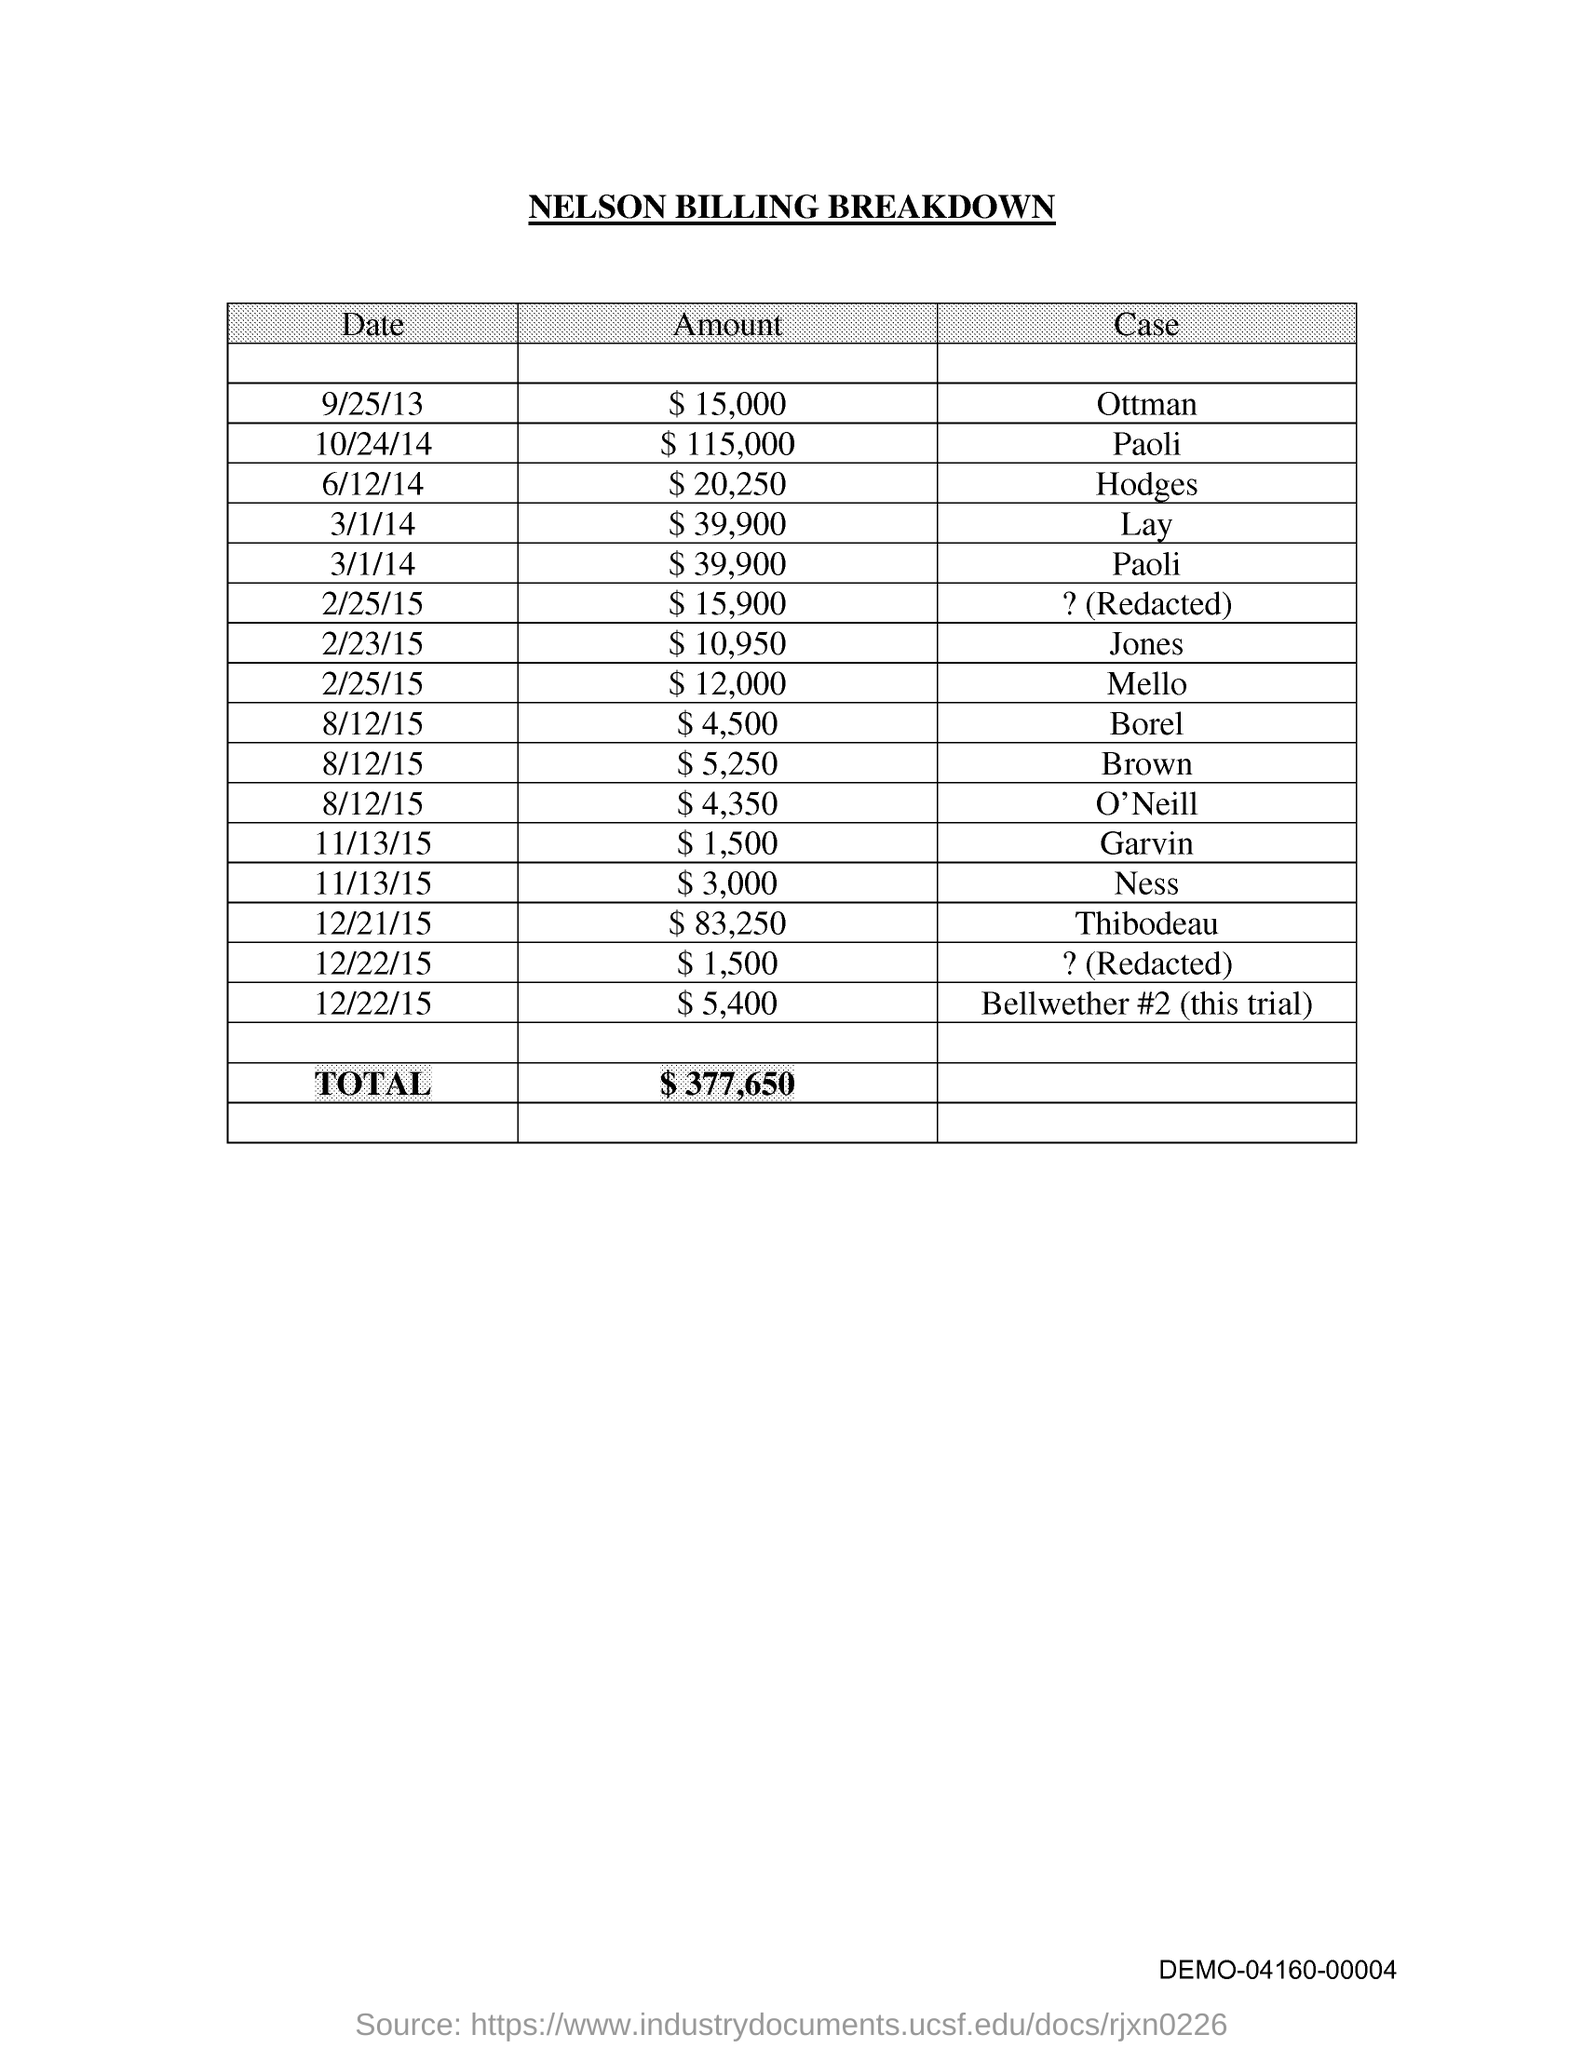What is the Total?
Offer a terse response. 377,650. 